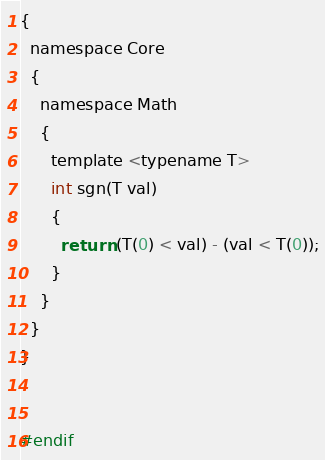Convert code to text. <code><loc_0><loc_0><loc_500><loc_500><_C_>{
  namespace Core
  {
    namespace Math
    {
      template <typename T>
      int sgn(T val)
      {
        return (T(0) < val) - (val < T(0));
      }
    }
  }
}


#endif
</code> 